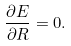<formula> <loc_0><loc_0><loc_500><loc_500>\frac { \partial E } { \partial R } = 0 .</formula> 